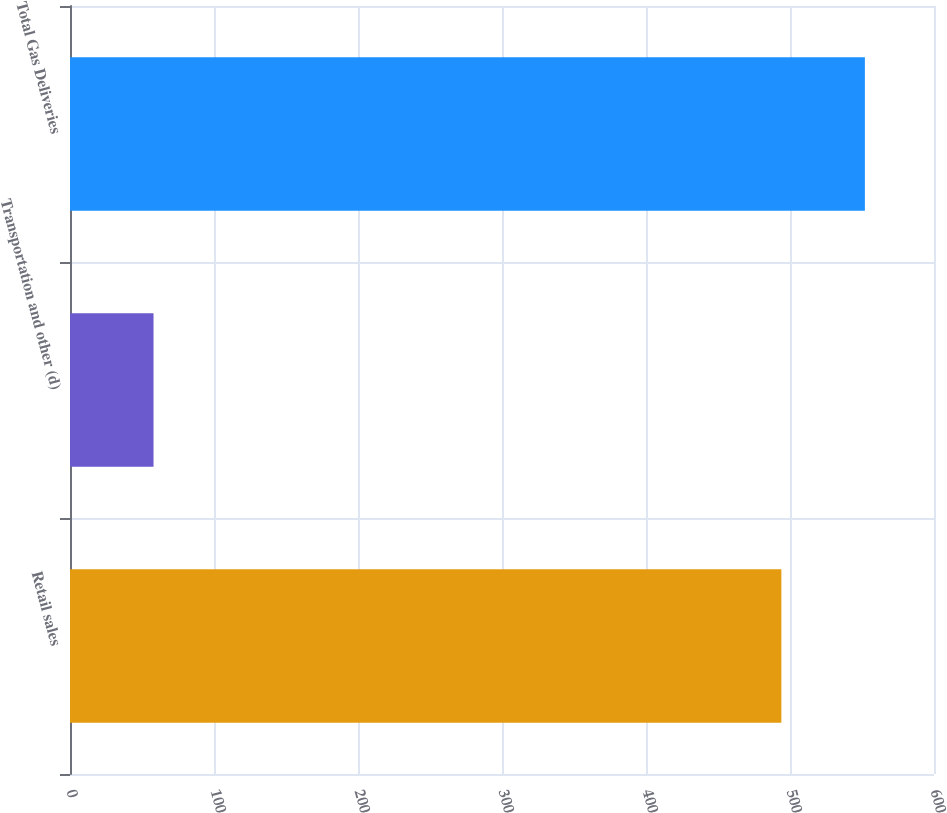Convert chart. <chart><loc_0><loc_0><loc_500><loc_500><bar_chart><fcel>Retail sales<fcel>Transportation and other (d)<fcel>Total Gas Deliveries<nl><fcel>494<fcel>58<fcel>552<nl></chart> 